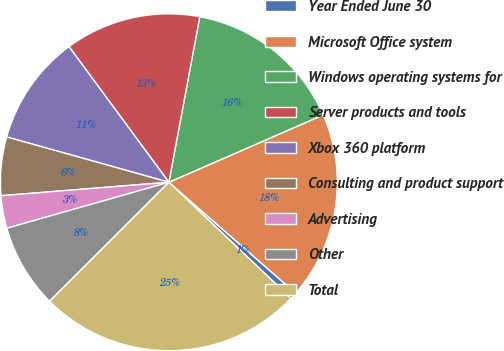Convert chart to OTSL. <chart><loc_0><loc_0><loc_500><loc_500><pie_chart><fcel>Year Ended June 30<fcel>Microsoft Office system<fcel>Windows operating systems for<fcel>Server products and tools<fcel>Xbox 360 platform<fcel>Consulting and product support<fcel>Advertising<fcel>Other<fcel>Total<nl><fcel>0.66%<fcel>17.99%<fcel>15.51%<fcel>13.04%<fcel>10.56%<fcel>5.61%<fcel>3.13%<fcel>8.08%<fcel>25.42%<nl></chart> 